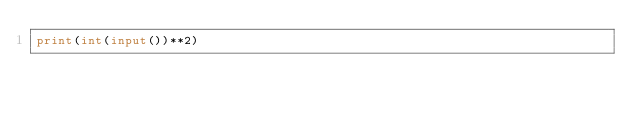<code> <loc_0><loc_0><loc_500><loc_500><_Python_>print(int(input())**2)</code> 